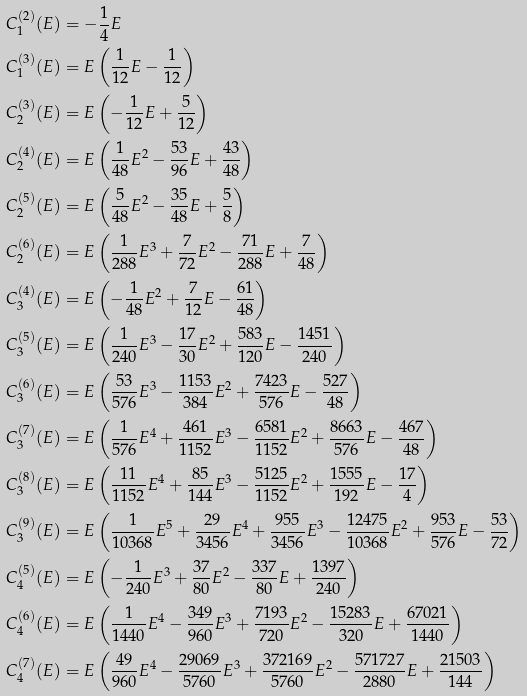<formula> <loc_0><loc_0><loc_500><loc_500>C _ { 1 } ^ { ( 2 ) } ( E ) & = - \frac { 1 } { 4 } E \\ C _ { 1 } ^ { ( 3 ) } ( E ) & = E \left ( \frac { 1 } { 1 2 } E - \frac { 1 } { 1 2 } \right ) \\ C _ { 2 } ^ { ( 3 ) } ( E ) & = E \left ( - \frac { 1 } { 1 2 } E + \frac { 5 } { 1 2 } \right ) \\ C _ { 2 } ^ { ( 4 ) } ( E ) & = E \left ( \frac { 1 } { 4 8 } E ^ { 2 } - \frac { 5 3 } { 9 6 } E + \frac { 4 3 } { 4 8 } \right ) \\ C _ { 2 } ^ { ( 5 ) } ( E ) & = E \left ( \frac { 5 } { 4 8 } E ^ { 2 } - \frac { 3 5 } { 4 8 } E + \frac { 5 } { 8 } \right ) \\ C _ { 2 } ^ { ( 6 ) } ( E ) & = E \left ( \frac { 1 } { 2 8 8 } E ^ { 3 } + \frac { 7 } { 7 2 } E ^ { 2 } - \frac { 7 1 } { 2 8 8 } E + \frac { 7 } { 4 8 } \right ) \\ C _ { 3 } ^ { ( 4 ) } ( E ) & = E \left ( - \frac { 1 } { 4 8 } E ^ { 2 } + \frac { 7 } { 1 2 } E - \frac { 6 1 } { 4 8 } \right ) \\ C _ { 3 } ^ { ( 5 ) } ( E ) & = E \left ( \frac { 1 } { 2 4 0 } E ^ { 3 } - \frac { 1 7 } { 3 0 } E ^ { 2 } + \frac { 5 8 3 } { 1 2 0 } E - \frac { 1 4 5 1 } { 2 4 0 } \right ) \\ C _ { 3 } ^ { ( 6 ) } ( E ) & = E \left ( \frac { 5 3 } { 5 7 6 } E ^ { 3 } - \frac { 1 1 5 3 } { 3 8 4 } E ^ { 2 } + \frac { 7 4 2 3 } { 5 7 6 } E - \frac { 5 2 7 } { 4 8 } \right ) \\ C _ { 3 } ^ { ( 7 ) } ( E ) & = E \left ( \frac { 1 } { 5 7 6 } E ^ { 4 } + \frac { 4 6 1 } { 1 1 5 2 } E ^ { 3 } - \frac { 6 5 8 1 } { 1 1 5 2 } E ^ { 2 } + \frac { 8 6 6 3 } { 5 7 6 } E - \frac { 4 6 7 } { 4 8 } \right ) \\ C _ { 3 } ^ { ( 8 ) } ( E ) & = E \left ( \frac { 1 1 } { 1 1 5 2 } E ^ { 4 } + \frac { 8 5 } { 1 4 4 } E ^ { 3 } - \frac { 5 1 2 5 } { 1 1 5 2 } E ^ { 2 } + \frac { 1 5 5 5 } { 1 9 2 } E - \frac { 1 7 } { 4 } \right ) \\ C _ { 3 } ^ { ( 9 ) } ( E ) & = E \left ( \frac { 1 } { 1 0 3 6 8 } E ^ { 5 } + \frac { 2 9 } { 3 4 5 6 } E ^ { 4 } + \frac { 9 5 5 } { 3 4 5 6 } E ^ { 3 } - \frac { 1 2 4 7 5 } { 1 0 3 6 8 } E ^ { 2 } + \frac { 9 5 3 } { 5 7 6 } E - \frac { 5 3 } { 7 2 } \right ) \\ C _ { 4 } ^ { ( 5 ) } ( E ) & = E \left ( - \frac { 1 } { 2 4 0 } E ^ { 3 } + \frac { 3 7 } { 8 0 } E ^ { 2 } - \frac { 3 3 7 } { 8 0 } E + \frac { 1 3 9 7 } { 2 4 0 } \right ) \\ C _ { 4 } ^ { ( 6 ) } ( E ) & = E \left ( \frac { 1 } { 1 4 4 0 } E ^ { 4 } - \frac { 3 4 9 } { 9 6 0 } E ^ { 3 } + \frac { 7 1 9 3 } { 7 2 0 } E ^ { 2 } - \frac { 1 5 2 8 3 } { 3 2 0 } E + \frac { 6 7 0 2 1 } { 1 4 4 0 } \right ) \\ C _ { 4 } ^ { ( 7 ) } ( E ) & = E \left ( \frac { 4 9 } { 9 6 0 } E ^ { 4 } - \frac { 2 9 0 6 9 } { 5 7 6 0 } E ^ { 3 } + \frac { 3 7 2 1 6 9 } { 5 7 6 0 } E ^ { 2 } - \frac { 5 7 1 7 2 7 } { 2 8 8 0 } E + \frac { 2 1 5 0 3 } { 1 4 4 } \right )</formula> 